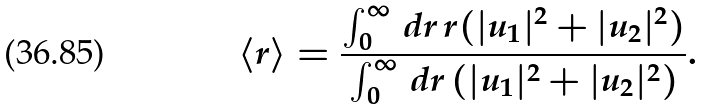<formula> <loc_0><loc_0><loc_500><loc_500>\langle r \rangle = \frac { \int _ { 0 } ^ { \infty } \, d r \, r ( | u _ { 1 } | ^ { 2 } + | u _ { 2 } | ^ { 2 } ) } { \int _ { 0 } ^ { \infty } \, d r \, ( | u _ { 1 } | ^ { 2 } + | u _ { 2 } | ^ { 2 } ) } .</formula> 